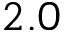Convert formula to latex. <formula><loc_0><loc_0><loc_500><loc_500>2 . 0</formula> 